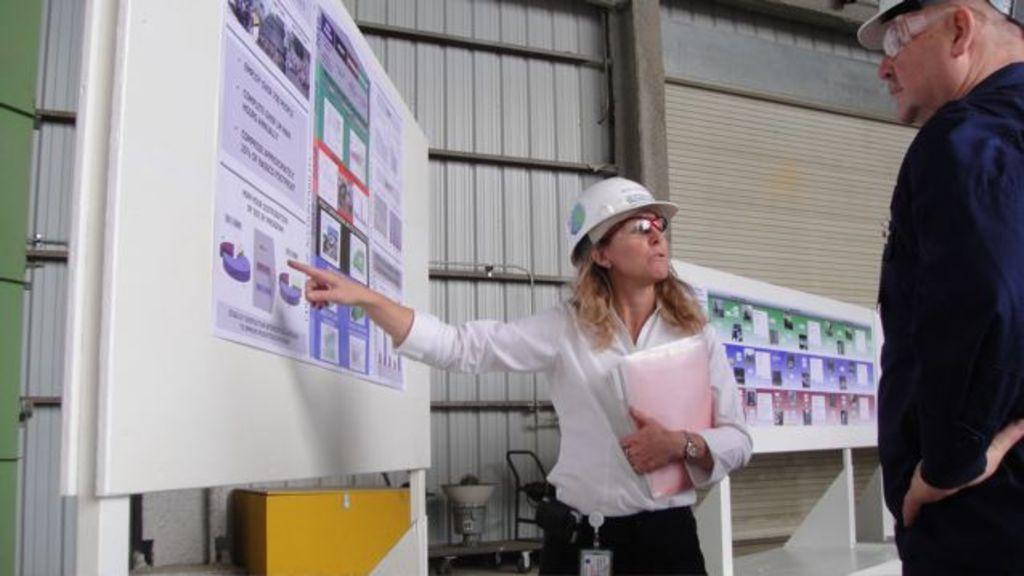In one or two sentences, can you explain what this image depicts? In this image there is a woman standing and holding a file in her hand, inside her there is a paper with some posters attached to it, on the posters there are some images and text on it. On the left side there is another person standing. In the background there are a few objects and there is a wall with metal sheets. 